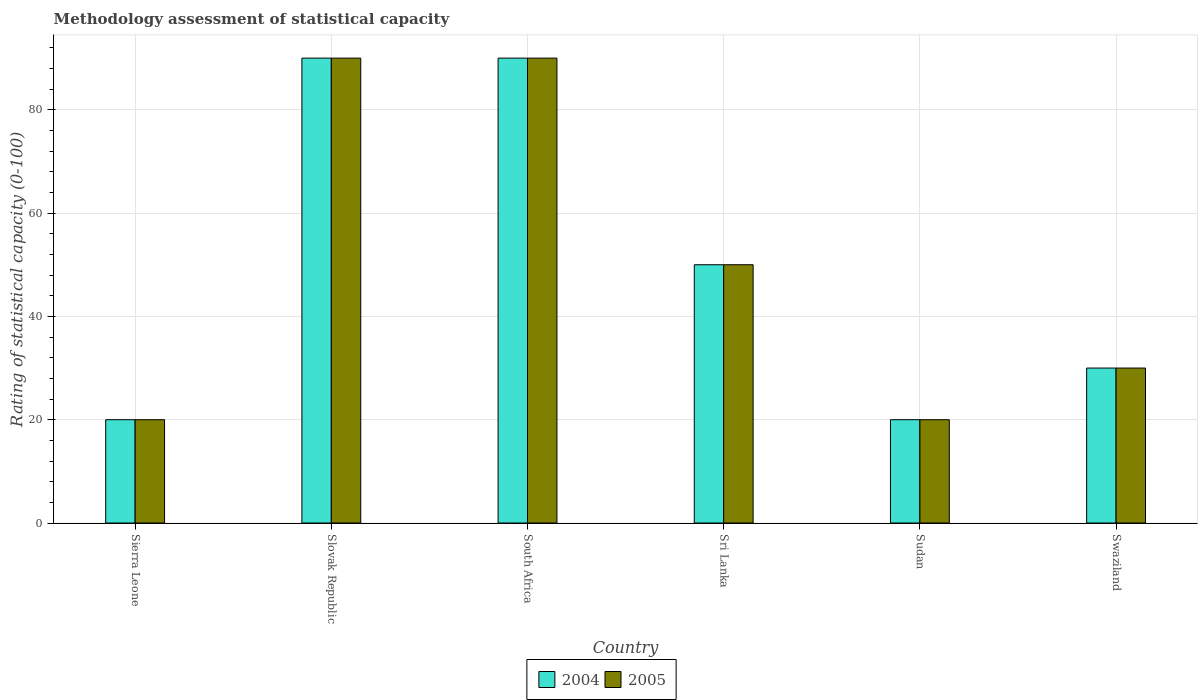How many different coloured bars are there?
Provide a short and direct response. 2. How many groups of bars are there?
Your answer should be very brief. 6. Are the number of bars on each tick of the X-axis equal?
Provide a succinct answer. Yes. How many bars are there on the 6th tick from the right?
Your answer should be very brief. 2. What is the label of the 4th group of bars from the left?
Ensure brevity in your answer.  Sri Lanka. In how many cases, is the number of bars for a given country not equal to the number of legend labels?
Your answer should be compact. 0. What is the rating of statistical capacity in 2005 in Swaziland?
Your response must be concise. 30. Across all countries, what is the minimum rating of statistical capacity in 2005?
Keep it short and to the point. 20. In which country was the rating of statistical capacity in 2005 maximum?
Offer a very short reply. Slovak Republic. In which country was the rating of statistical capacity in 2005 minimum?
Give a very brief answer. Sierra Leone. What is the total rating of statistical capacity in 2005 in the graph?
Give a very brief answer. 300. What is the difference between the rating of statistical capacity in 2005 in Sri Lanka and the rating of statistical capacity in 2004 in Slovak Republic?
Your answer should be very brief. -40. What is the average rating of statistical capacity in 2005 per country?
Keep it short and to the point. 50. In how many countries, is the rating of statistical capacity in 2005 greater than 16?
Your answer should be compact. 6. Is the rating of statistical capacity in 2004 in Slovak Republic less than that in Swaziland?
Provide a short and direct response. No. In how many countries, is the rating of statistical capacity in 2005 greater than the average rating of statistical capacity in 2005 taken over all countries?
Give a very brief answer. 2. Is the sum of the rating of statistical capacity in 2005 in Sudan and Swaziland greater than the maximum rating of statistical capacity in 2004 across all countries?
Offer a terse response. No. What does the 1st bar from the right in Slovak Republic represents?
Provide a short and direct response. 2005. What is the difference between two consecutive major ticks on the Y-axis?
Your response must be concise. 20. Are the values on the major ticks of Y-axis written in scientific E-notation?
Your answer should be very brief. No. Does the graph contain grids?
Your response must be concise. Yes. What is the title of the graph?
Provide a short and direct response. Methodology assessment of statistical capacity. What is the label or title of the X-axis?
Offer a very short reply. Country. What is the label or title of the Y-axis?
Ensure brevity in your answer.  Rating of statistical capacity (0-100). What is the Rating of statistical capacity (0-100) in 2004 in Sierra Leone?
Make the answer very short. 20. What is the Rating of statistical capacity (0-100) of 2005 in Sierra Leone?
Keep it short and to the point. 20. What is the Rating of statistical capacity (0-100) of 2005 in Slovak Republic?
Make the answer very short. 90. What is the Rating of statistical capacity (0-100) of 2004 in South Africa?
Your response must be concise. 90. What is the Rating of statistical capacity (0-100) in 2005 in Sri Lanka?
Offer a very short reply. 50. What is the Rating of statistical capacity (0-100) of 2004 in Swaziland?
Provide a short and direct response. 30. What is the Rating of statistical capacity (0-100) in 2005 in Swaziland?
Your answer should be very brief. 30. Across all countries, what is the maximum Rating of statistical capacity (0-100) of 2005?
Give a very brief answer. 90. Across all countries, what is the minimum Rating of statistical capacity (0-100) in 2005?
Provide a short and direct response. 20. What is the total Rating of statistical capacity (0-100) of 2004 in the graph?
Offer a terse response. 300. What is the total Rating of statistical capacity (0-100) of 2005 in the graph?
Provide a short and direct response. 300. What is the difference between the Rating of statistical capacity (0-100) in 2004 in Sierra Leone and that in Slovak Republic?
Offer a very short reply. -70. What is the difference between the Rating of statistical capacity (0-100) in 2005 in Sierra Leone and that in Slovak Republic?
Give a very brief answer. -70. What is the difference between the Rating of statistical capacity (0-100) of 2004 in Sierra Leone and that in South Africa?
Provide a short and direct response. -70. What is the difference between the Rating of statistical capacity (0-100) in 2005 in Sierra Leone and that in South Africa?
Give a very brief answer. -70. What is the difference between the Rating of statistical capacity (0-100) in 2004 in Sierra Leone and that in Sri Lanka?
Your answer should be very brief. -30. What is the difference between the Rating of statistical capacity (0-100) of 2004 in Sierra Leone and that in Swaziland?
Keep it short and to the point. -10. What is the difference between the Rating of statistical capacity (0-100) of 2004 in Slovak Republic and that in South Africa?
Make the answer very short. 0. What is the difference between the Rating of statistical capacity (0-100) in 2005 in Slovak Republic and that in South Africa?
Provide a succinct answer. 0. What is the difference between the Rating of statistical capacity (0-100) in 2005 in Slovak Republic and that in Sri Lanka?
Make the answer very short. 40. What is the difference between the Rating of statistical capacity (0-100) in 2004 in Slovak Republic and that in Swaziland?
Give a very brief answer. 60. What is the difference between the Rating of statistical capacity (0-100) of 2004 in South Africa and that in Sri Lanka?
Your response must be concise. 40. What is the difference between the Rating of statistical capacity (0-100) of 2005 in South Africa and that in Sri Lanka?
Give a very brief answer. 40. What is the difference between the Rating of statistical capacity (0-100) of 2004 in Sudan and that in Swaziland?
Ensure brevity in your answer.  -10. What is the difference between the Rating of statistical capacity (0-100) in 2005 in Sudan and that in Swaziland?
Give a very brief answer. -10. What is the difference between the Rating of statistical capacity (0-100) in 2004 in Sierra Leone and the Rating of statistical capacity (0-100) in 2005 in Slovak Republic?
Provide a succinct answer. -70. What is the difference between the Rating of statistical capacity (0-100) of 2004 in Sierra Leone and the Rating of statistical capacity (0-100) of 2005 in South Africa?
Provide a short and direct response. -70. What is the difference between the Rating of statistical capacity (0-100) of 2004 in Sierra Leone and the Rating of statistical capacity (0-100) of 2005 in Sri Lanka?
Offer a very short reply. -30. What is the difference between the Rating of statistical capacity (0-100) of 2004 in Sierra Leone and the Rating of statistical capacity (0-100) of 2005 in Sudan?
Provide a short and direct response. 0. What is the difference between the Rating of statistical capacity (0-100) of 2004 in Sierra Leone and the Rating of statistical capacity (0-100) of 2005 in Swaziland?
Give a very brief answer. -10. What is the difference between the Rating of statistical capacity (0-100) of 2004 in Slovak Republic and the Rating of statistical capacity (0-100) of 2005 in Sri Lanka?
Your response must be concise. 40. What is the difference between the Rating of statistical capacity (0-100) of 2004 in Slovak Republic and the Rating of statistical capacity (0-100) of 2005 in Sudan?
Offer a terse response. 70. What is the difference between the Rating of statistical capacity (0-100) of 2004 in Slovak Republic and the Rating of statistical capacity (0-100) of 2005 in Swaziland?
Give a very brief answer. 60. What is the difference between the Rating of statistical capacity (0-100) in 2004 in South Africa and the Rating of statistical capacity (0-100) in 2005 in Sudan?
Provide a short and direct response. 70. What is the average Rating of statistical capacity (0-100) in 2004 per country?
Ensure brevity in your answer.  50. What is the average Rating of statistical capacity (0-100) in 2005 per country?
Keep it short and to the point. 50. What is the difference between the Rating of statistical capacity (0-100) in 2004 and Rating of statistical capacity (0-100) in 2005 in Sierra Leone?
Ensure brevity in your answer.  0. What is the difference between the Rating of statistical capacity (0-100) of 2004 and Rating of statistical capacity (0-100) of 2005 in Sri Lanka?
Offer a terse response. 0. What is the ratio of the Rating of statistical capacity (0-100) of 2004 in Sierra Leone to that in Slovak Republic?
Offer a very short reply. 0.22. What is the ratio of the Rating of statistical capacity (0-100) of 2005 in Sierra Leone to that in Slovak Republic?
Your answer should be compact. 0.22. What is the ratio of the Rating of statistical capacity (0-100) of 2004 in Sierra Leone to that in South Africa?
Your answer should be compact. 0.22. What is the ratio of the Rating of statistical capacity (0-100) in 2005 in Sierra Leone to that in South Africa?
Offer a terse response. 0.22. What is the ratio of the Rating of statistical capacity (0-100) of 2004 in Sierra Leone to that in Sri Lanka?
Keep it short and to the point. 0.4. What is the ratio of the Rating of statistical capacity (0-100) in 2005 in Sierra Leone to that in Sudan?
Provide a short and direct response. 1. What is the ratio of the Rating of statistical capacity (0-100) of 2004 in Sierra Leone to that in Swaziland?
Give a very brief answer. 0.67. What is the ratio of the Rating of statistical capacity (0-100) in 2004 in Slovak Republic to that in South Africa?
Your response must be concise. 1. What is the ratio of the Rating of statistical capacity (0-100) in 2004 in Slovak Republic to that in Sri Lanka?
Keep it short and to the point. 1.8. What is the ratio of the Rating of statistical capacity (0-100) of 2005 in Slovak Republic to that in Sri Lanka?
Your answer should be very brief. 1.8. What is the ratio of the Rating of statistical capacity (0-100) of 2004 in Slovak Republic to that in Sudan?
Provide a succinct answer. 4.5. What is the ratio of the Rating of statistical capacity (0-100) of 2005 in Slovak Republic to that in Sudan?
Keep it short and to the point. 4.5. What is the ratio of the Rating of statistical capacity (0-100) of 2004 in Slovak Republic to that in Swaziland?
Your response must be concise. 3. What is the ratio of the Rating of statistical capacity (0-100) of 2005 in Slovak Republic to that in Swaziland?
Offer a terse response. 3. What is the ratio of the Rating of statistical capacity (0-100) of 2004 in South Africa to that in Sri Lanka?
Your answer should be compact. 1.8. What is the ratio of the Rating of statistical capacity (0-100) in 2005 in South Africa to that in Sri Lanka?
Provide a short and direct response. 1.8. What is the ratio of the Rating of statistical capacity (0-100) in 2005 in South Africa to that in Sudan?
Your response must be concise. 4.5. What is the ratio of the Rating of statistical capacity (0-100) of 2004 in South Africa to that in Swaziland?
Your answer should be compact. 3. What is the ratio of the Rating of statistical capacity (0-100) of 2005 in South Africa to that in Swaziland?
Your response must be concise. 3. What is the ratio of the Rating of statistical capacity (0-100) of 2004 in Sri Lanka to that in Sudan?
Your answer should be very brief. 2.5. What is the ratio of the Rating of statistical capacity (0-100) of 2005 in Sri Lanka to that in Sudan?
Keep it short and to the point. 2.5. What is the ratio of the Rating of statistical capacity (0-100) of 2005 in Sri Lanka to that in Swaziland?
Make the answer very short. 1.67. What is the difference between the highest and the second highest Rating of statistical capacity (0-100) in 2005?
Keep it short and to the point. 0. What is the difference between the highest and the lowest Rating of statistical capacity (0-100) of 2005?
Your answer should be very brief. 70. 